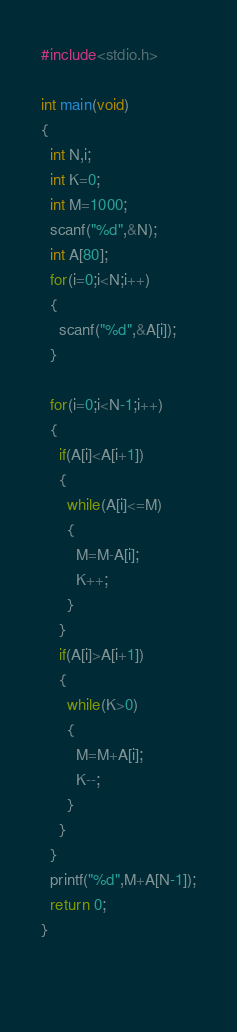<code> <loc_0><loc_0><loc_500><loc_500><_C_>#include<stdio.h>

int main(void)
{
  int N,i;
  int K=0;
  int M=1000;
  scanf("%d",&N);
  int A[80];
  for(i=0;i<N;i++)
  {
    scanf("%d",&A[i]);
  }
  
  for(i=0;i<N-1;i++)
  {
    if(A[i]<A[i+1])
    {
      while(A[i]<=M)
      {
        M=M-A[i];
        K++;
      }
    }
    if(A[i]>A[i+1])
    {
      while(K>0)
      {
        M=M+A[i];
        K--;
      }
    }
  }
  printf("%d",M+A[N-1]);
  return 0;
}
        
  </code> 